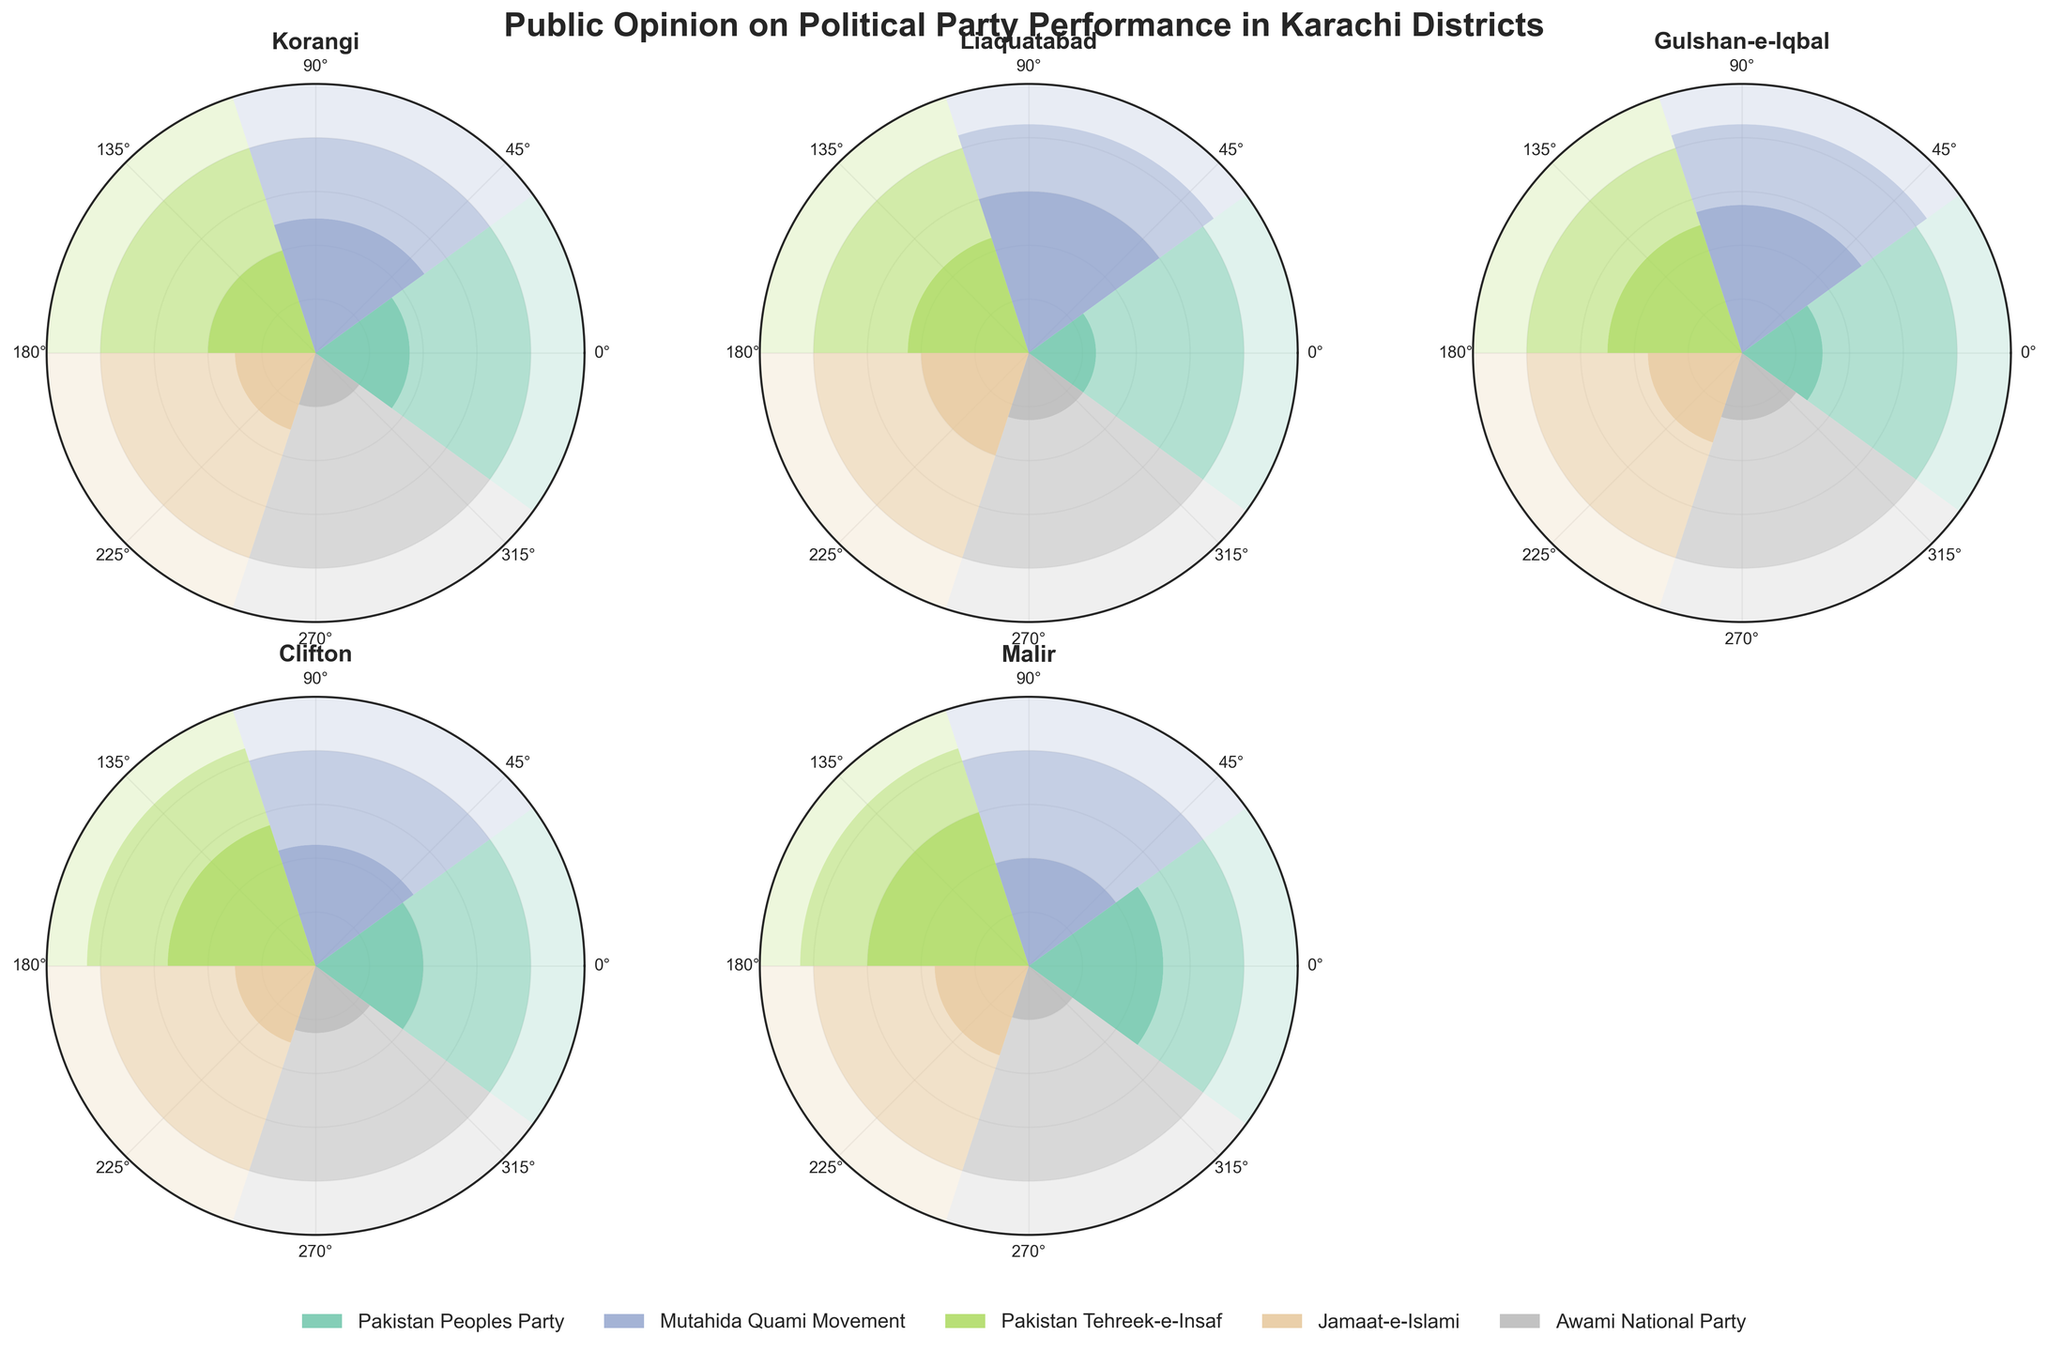Which district has the highest positive opinion for Pakistan Tehreek-e-Insaf? To find the district with the highest positive opinion for Pakistan Tehreek-e-Insaf, look at the corresponding bars for PTI in each subplot and compare the heights of the positive sections (the bottom part of the bars). Malir shows a 60% positive opinion, which is the highest among all districts.
Answer: Malir Which party has the lowest positive opinion in Clifton? In the subplot for Clifton, compare the heights of the positive sections of the bars for each party. Awami National Party has the lowest positive opinion with only 25%.
Answer: Awami National Party What is the sum of the neutral opinions for Mutahida Quami Movement across all districts? Add the neutral opinion percentages for Mutahida Quami Movement for Korangi (20%), Liaquatabad (15%), Gulshan-e-Iqbal (15%), Clifton (20%), and Malir (20%). The calculation is 20 + 15 + 15 + 20 + 20 = 90.
Answer: 90 In which district does Pakistan Peoples Party have an equal percentage of negative and neutral opinions? Look at the subplots for each district and check the bar segments for Pakistan Peoples Party. Both Korangi and Malir have Pakistan Peoples Party showing 20% neutral and 40% negative opinions in Korangi and 30% in Malir.
Answer: None Which party has the highest variance in positive opinions across all districts? Calculate the variance of the positive opinions for each party across the districts. PPP: 35, 25, 30, 40, 50; MQM: 50, 60, 55, 45, 40; PTI: 40, 45, 50, 55, 60; JI: 30, 40, 35, 30, 35; ANP: 20, 25, 25, 25, 20. The variance for PTI is the highest given the spread of its values.
Answer: Pakistan Tehreek-e-Insaf 